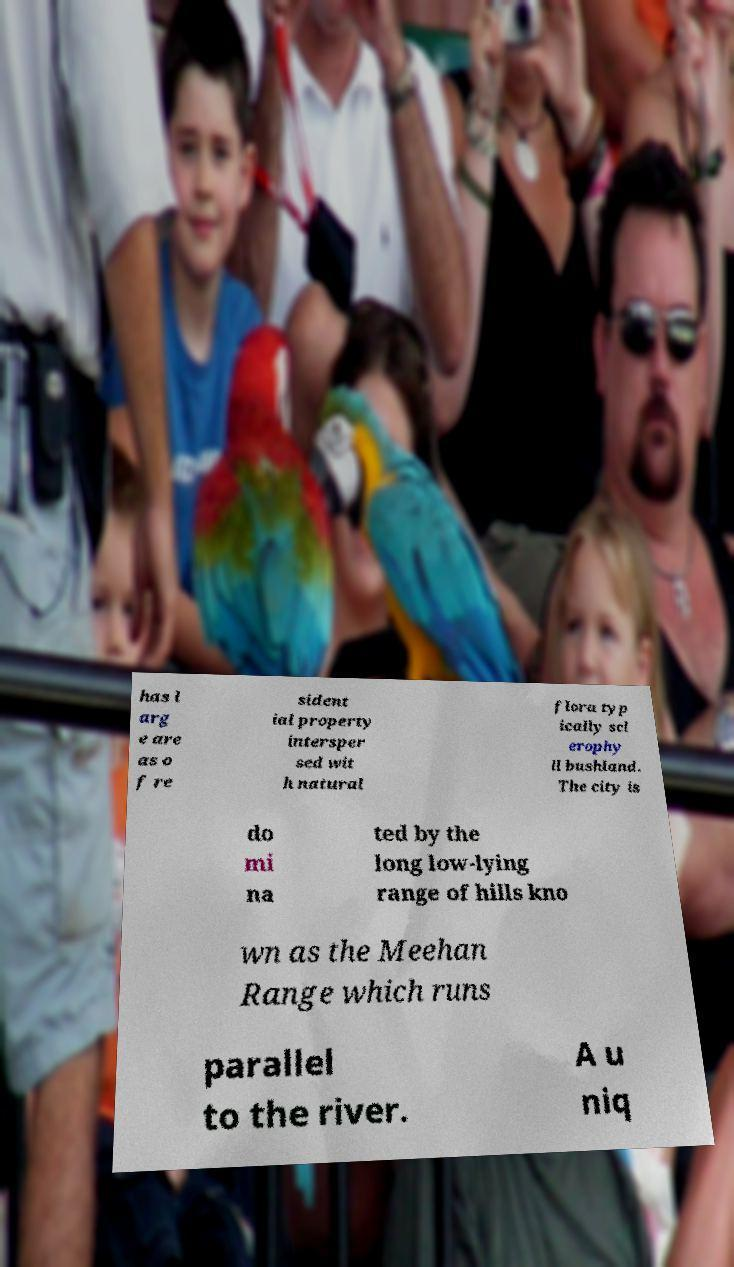Could you extract and type out the text from this image? has l arg e are as o f re sident ial property intersper sed wit h natural flora typ ically scl erophy ll bushland. The city is do mi na ted by the long low-lying range of hills kno wn as the Meehan Range which runs parallel to the river. A u niq 